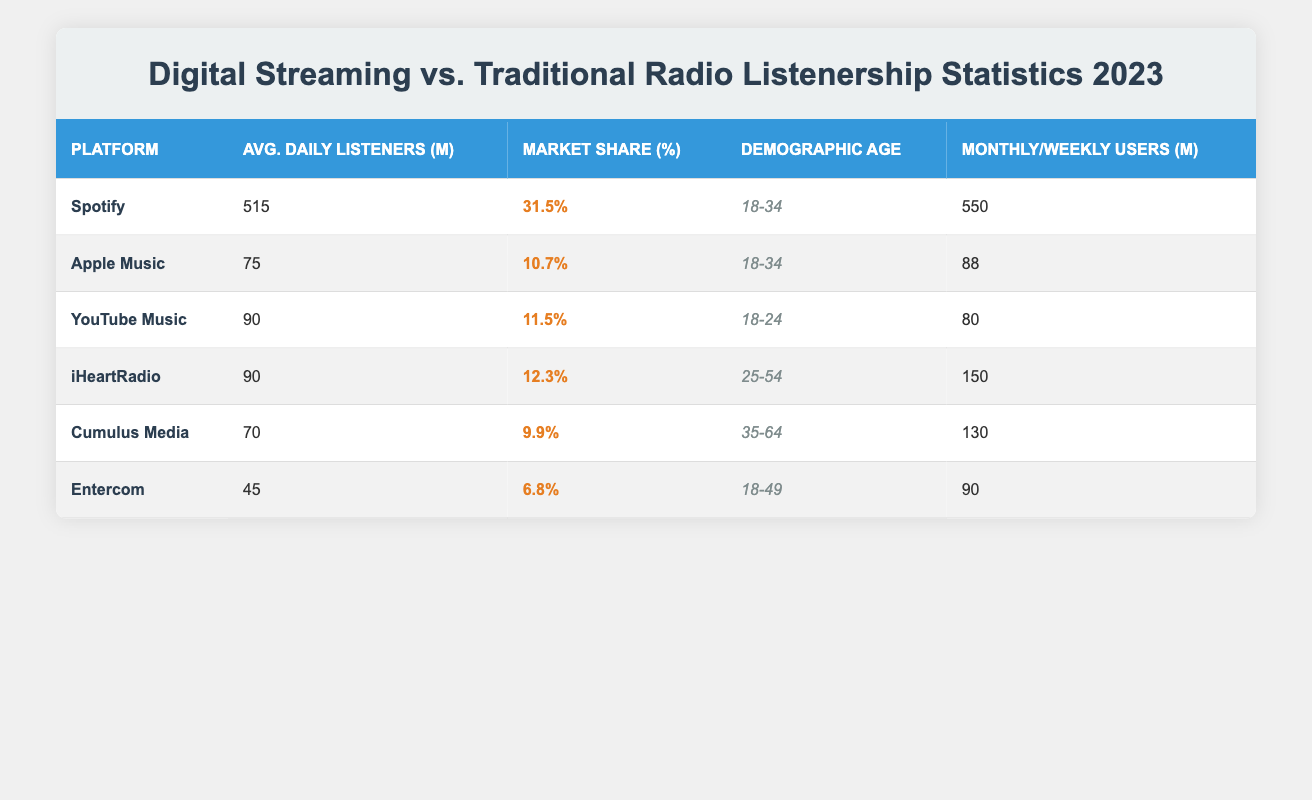What is the average daily listenership for Spotify? The table lists Spotify's average daily listeners as 515 million. This value is stated directly under the "Avg. Daily Listeners (M)" column for Spotify.
Answer: 515 million Which platform has the largest market share and what is it? By reviewing the "Market Share (%)" column, Spotify is identified as having the largest market share at 31.5%.
Answer: Spotify, 31.5% Does YouTube Music have a higher average daily listener count than Cumulus Media? YouTube Music has 90 million average daily listeners while Cumulus Media has 70 million. Since 90 is greater than 70, the answer is yes.
Answer: Yes What is the total average daily listenership for all traditional radio stations listed? Adding the average daily listeners for iHeartRadio (90), Cumulus Media (70), and Entercom (45) gives a total of 90 + 70 + 45 = 205 million.
Answer: 205 million Is the demographic age for Apple Music the same as that for Spotify? Both Apple Music and Spotify target the same demographic age range of 18-34 years. Therefore, the statement is true.
Answer: Yes What percentage of users from Spotify's monthly active users are average daily listeners? Spotify has 550 million monthly active users and 515 million average daily listeners. The percentage is calculated as (515/550) * 100, which equals approximately 93.64%.
Answer: Approximately 93.64% Which traditional radio station has the least average daily listeners and what is the count? Among traditional radio stations, Entercom has the least average daily listeners at 45 million. This is found by comparing all average daily listener figures in the "Avg. Daily Listeners (M)" column.
Answer: Entercom, 45 million What is the difference in market share between Spotify and Entercom? Spotify's market share is 31.5%, while Entercom's is 6.8%. The difference is calculated as 31.5 - 6.8 = 24.7%.
Answer: 24.7% Does iHeartRadio have more weekly listeners than Apple Music has monthly active users? iHeartRadio has 150 million weekly listeners compared to Apple Music's 88 million monthly active users. Since 150 is greater than 88, the answer is yes.
Answer: Yes 